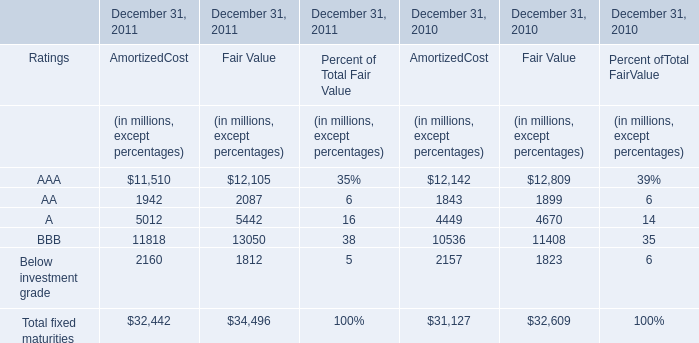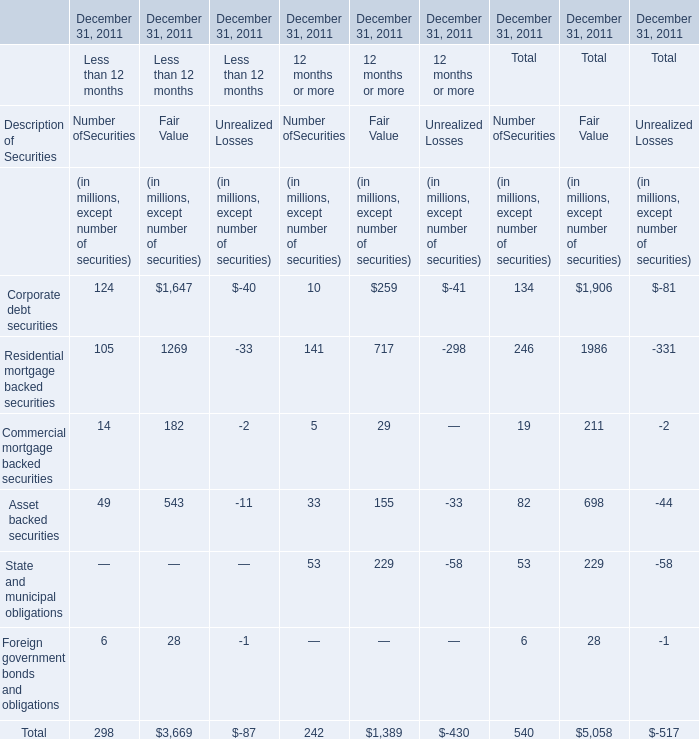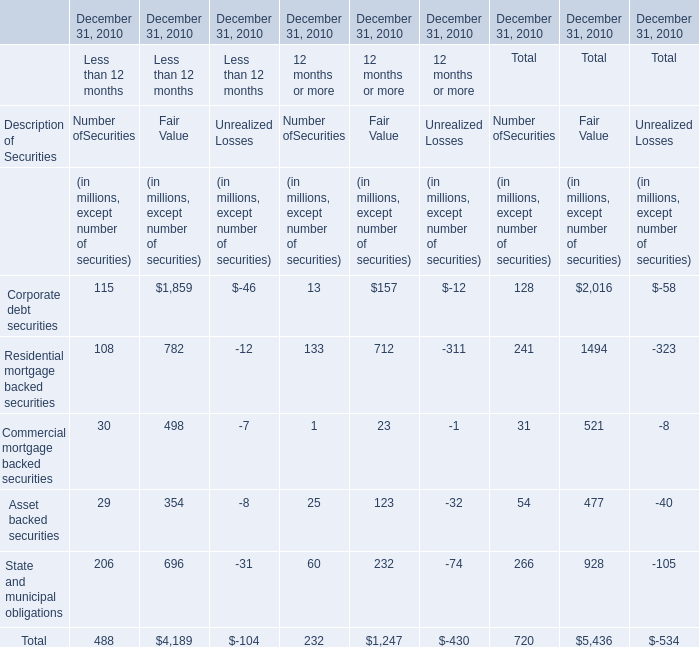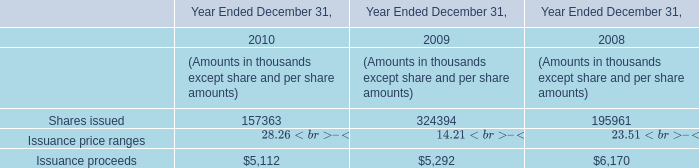What's the growth rate of AmortizedCost of AA in 2011? 
Computations: ((1942 - 1843) / 1843)
Answer: 0.05372. 